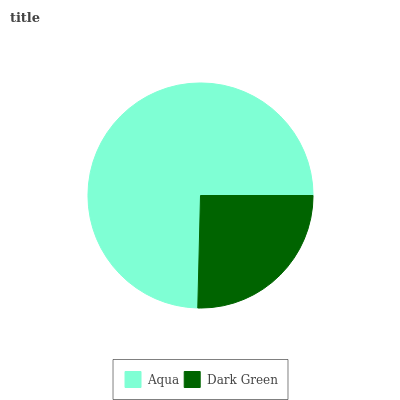Is Dark Green the minimum?
Answer yes or no. Yes. Is Aqua the maximum?
Answer yes or no. Yes. Is Dark Green the maximum?
Answer yes or no. No. Is Aqua greater than Dark Green?
Answer yes or no. Yes. Is Dark Green less than Aqua?
Answer yes or no. Yes. Is Dark Green greater than Aqua?
Answer yes or no. No. Is Aqua less than Dark Green?
Answer yes or no. No. Is Aqua the high median?
Answer yes or no. Yes. Is Dark Green the low median?
Answer yes or no. Yes. Is Dark Green the high median?
Answer yes or no. No. Is Aqua the low median?
Answer yes or no. No. 